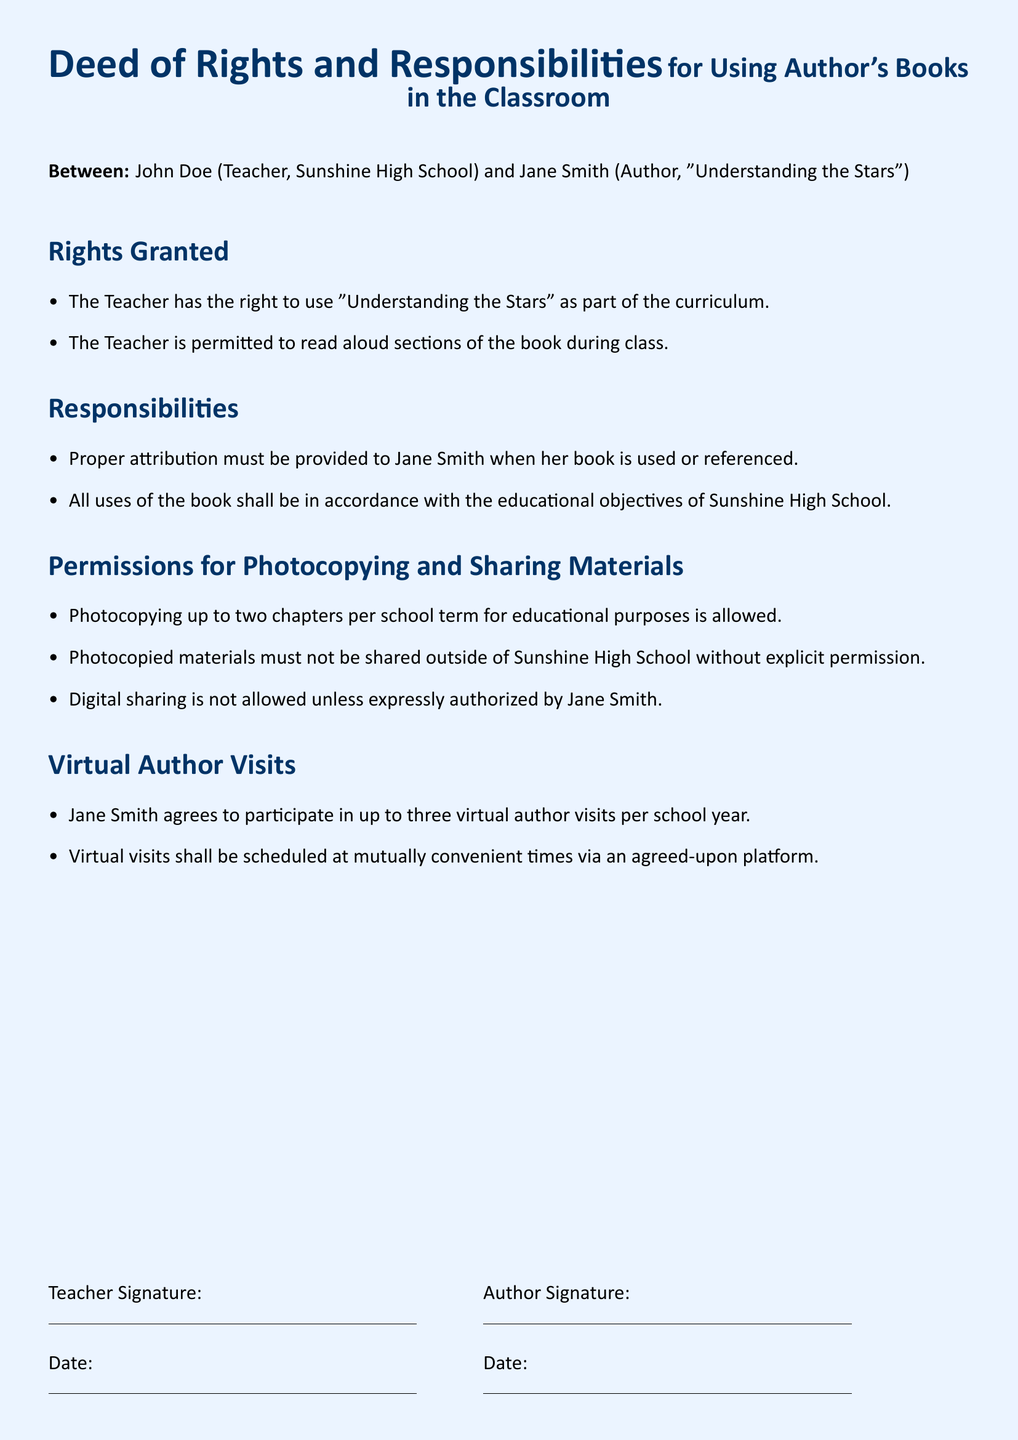What is the title of the author's book? The title of the author's book is mentioned in the document.
Answer: Understanding the Stars Who is the author of the book? The document specifies the author's name and role at the beginning.
Answer: Jane Smith How many virtual author visits can Jane Smith participate in per school year? The document states the number of author visits Jane Smith agrees to participate in each year.
Answer: up to three What is the maximum number of chapters that can be photocopied per school term? The document outlines the restrictions on photocopying chapters for educational use.
Answer: two What must be provided when using or referencing the author's book? The document specifies the requirement when using the book in the classroom.
Answer: proper attribution Are photocopied materials allowed to be shared outside of the school? The document states the limitations on sharing photocopied materials.
Answer: no What is the name of the teacher involved in this Deed? The document includes the teacher's name and position.
Answer: John Doe What type of document is this? The structure and content of the document indicate a particular format and purpose.
Answer: signed Deed When was the Deed signed? The document provides space for the date of signing.
Answer: Date not specified 